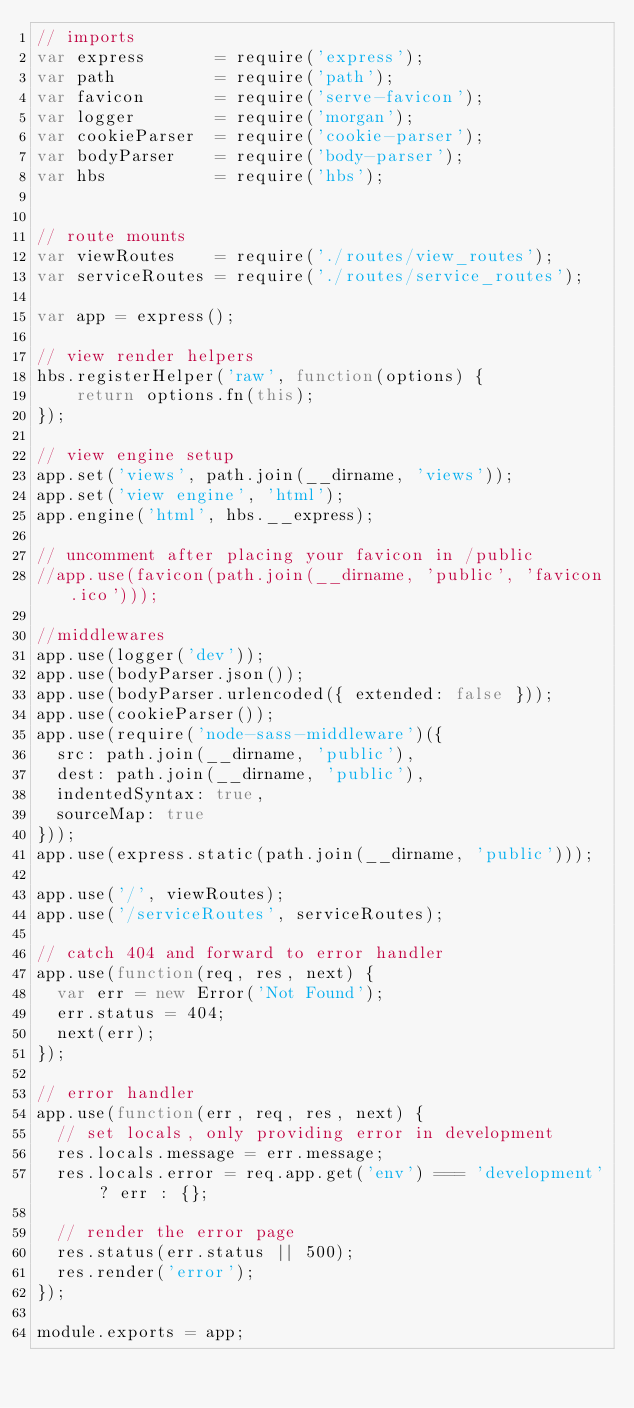Convert code to text. <code><loc_0><loc_0><loc_500><loc_500><_JavaScript_>// imports
var express       = require('express');
var path          = require('path');
var favicon       = require('serve-favicon');
var logger        = require('morgan');
var cookieParser  = require('cookie-parser');
var bodyParser    = require('body-parser');
var hbs           = require('hbs');


// route mounts
var viewRoutes    = require('./routes/view_routes');
var serviceRoutes = require('./routes/service_routes');

var app = express();

// view render helpers
hbs.registerHelper('raw', function(options) {
    return options.fn(this);
});

// view engine setup
app.set('views', path.join(__dirname, 'views'));
app.set('view engine', 'html');
app.engine('html', hbs.__express);

// uncomment after placing your favicon in /public
//app.use(favicon(path.join(__dirname, 'public', 'favicon.ico')));

//middlewares
app.use(logger('dev'));
app.use(bodyParser.json());
app.use(bodyParser.urlencoded({ extended: false }));
app.use(cookieParser());
app.use(require('node-sass-middleware')({
  src: path.join(__dirname, 'public'),
  dest: path.join(__dirname, 'public'),
  indentedSyntax: true,
  sourceMap: true
}));
app.use(express.static(path.join(__dirname, 'public')));

app.use('/', viewRoutes);
app.use('/serviceRoutes', serviceRoutes);

// catch 404 and forward to error handler
app.use(function(req, res, next) {
  var err = new Error('Not Found');
  err.status = 404;
  next(err);
});

// error handler
app.use(function(err, req, res, next) {
  // set locals, only providing error in development
  res.locals.message = err.message;
  res.locals.error = req.app.get('env') === 'development' ? err : {};

  // render the error page
  res.status(err.status || 500);
  res.render('error');
});

module.exports = app;
</code> 